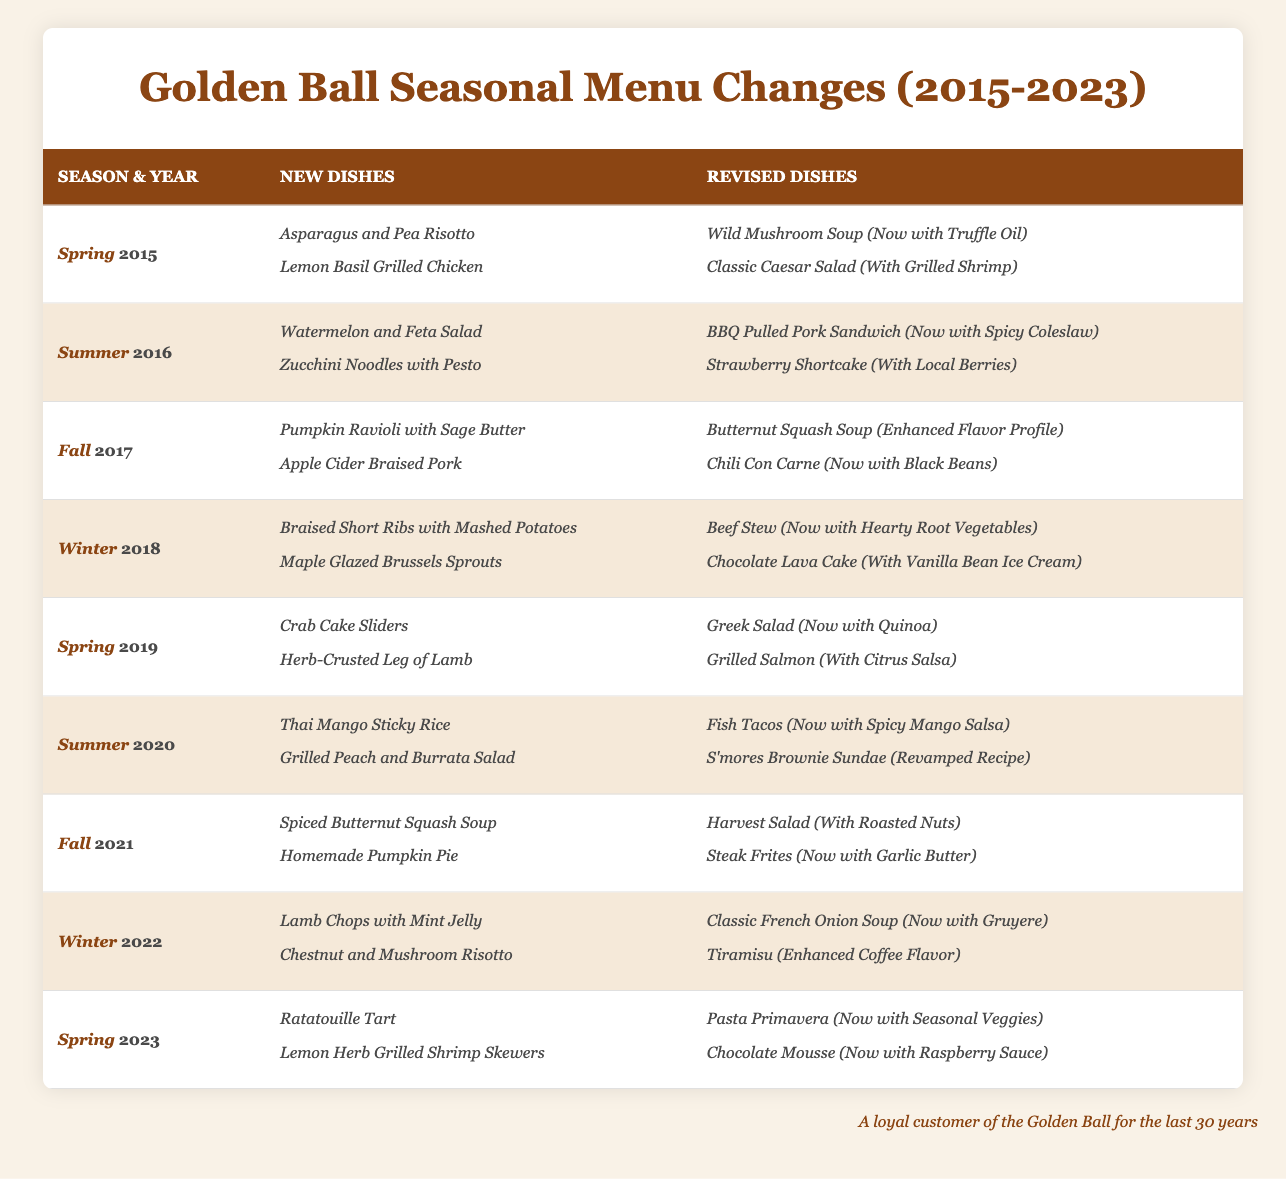What new dishes were offered in Fall 2017? According to the table, the new dishes for Fall 2017 were _Pumpkin Ravioli with Sage Butter_ and _Apple Cider Braised Pork_.
Answer: _Pumpkin Ravioli with Sage Butter_ and _Apple Cider Braised Pork_ Which season had the highest number of new dishes introduced between 2015 and 2023? By examining the table, I see that every season typically has two new dishes, so there is no single season with more new dishes than the others.
Answer: Every season had two new dishes Did any seasonal menus have revised dishes that included vegetables? Looking through the table, I notice that multiple revised dishes include vegetables, such as _Butternut Squash Soup (Enhanced Flavor Profile)_ and _Harvest Salad (With Roasted Nuts)_.
Answer: Yes How many unique new dishes were introduced from 2015 to 2023? I count the new dishes listed over the seasons from 2015 to 2023. There are 18 distinct new dishes mentioned in total over these seasons.
Answer: 18 In which year did _Thai Mango Sticky Rice_ make its debut? The table indicates that _Thai Mango Sticky Rice_ was introduced in the Summer of 2020.
Answer: 2020 Was there a revised dish in Winter 2022 that had an enhanced flavor? The table shows that _Tiramisu (Enhanced Coffee Flavor)_ was a revised dish in Winter 2022, indicating it had an enhanced flavor.
Answer: Yes What is the most recent new dish added in the table? The latest season is Spring 2023, where _Ratatouille Tart_ and _Lemon Herb Grilled Shrimp Skewers_ are the most recent new dishes added.
Answer: _Ratatouille Tart_ and _Lemon Herb Grilled Shrimp Skewers_ How many seasons saw the introduction of _soup_ dishes from 2015 to 2023? Referring to the table, I see that there are three seasons that introduced new soups: Spring 2019 with _Crab Cake Sliders_, Fall 2017 with _Pumpkin Ravioli_, and Fall 2021 with _Spiced Butternut Squash Soup_.
Answer: 3 Which dish was reintroduced with a new twist in Winter 2018? The table lists _Beef Stew (Now with Hearty Root Vegetables)_ as a revised dish in Winter 2018, indicating it was reintroduced with a new twist.
Answer: _Beef Stew (Now with Hearty Root Vegetables)_ How does the number of new dishes in Spring 2019 compare to Winter 2022? Both Spring 2019 and Winter 2022 introduced two new dishes each, making the comparison equal with no variation.
Answer: They are equal; both had two new dishes 